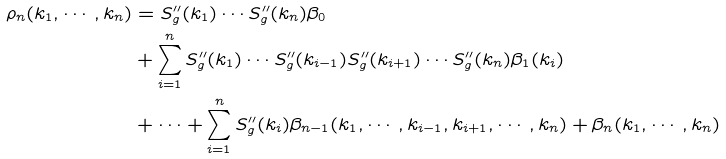Convert formula to latex. <formula><loc_0><loc_0><loc_500><loc_500>\rho _ { n } ( k _ { 1 } , \cdots , k _ { n } ) & = S ^ { \prime \prime } _ { g } ( k _ { 1 } ) \cdots S ^ { \prime \prime } _ { g } ( k _ { n } ) \beta _ { 0 } \\ & + \sum _ { i = 1 } ^ { n } S ^ { \prime \prime } _ { g } ( k _ { 1 } ) \cdots S ^ { \prime \prime } _ { g } ( k _ { i - 1 } ) S ^ { \prime \prime } _ { g } ( k _ { i + 1 } ) \cdots S ^ { \prime \prime } _ { g } ( k _ { n } ) \beta _ { 1 } ( k _ { i } ) \\ & + \cdots + \sum _ { i = 1 } ^ { n } S ^ { \prime \prime } _ { g } ( k _ { i } ) \beta _ { n - 1 } ( k _ { 1 } , \cdots , k _ { i - 1 } , k _ { i + 1 } , \cdots , k _ { n } ) + \beta _ { n } ( k _ { 1 } , \cdots , k _ { n } )</formula> 